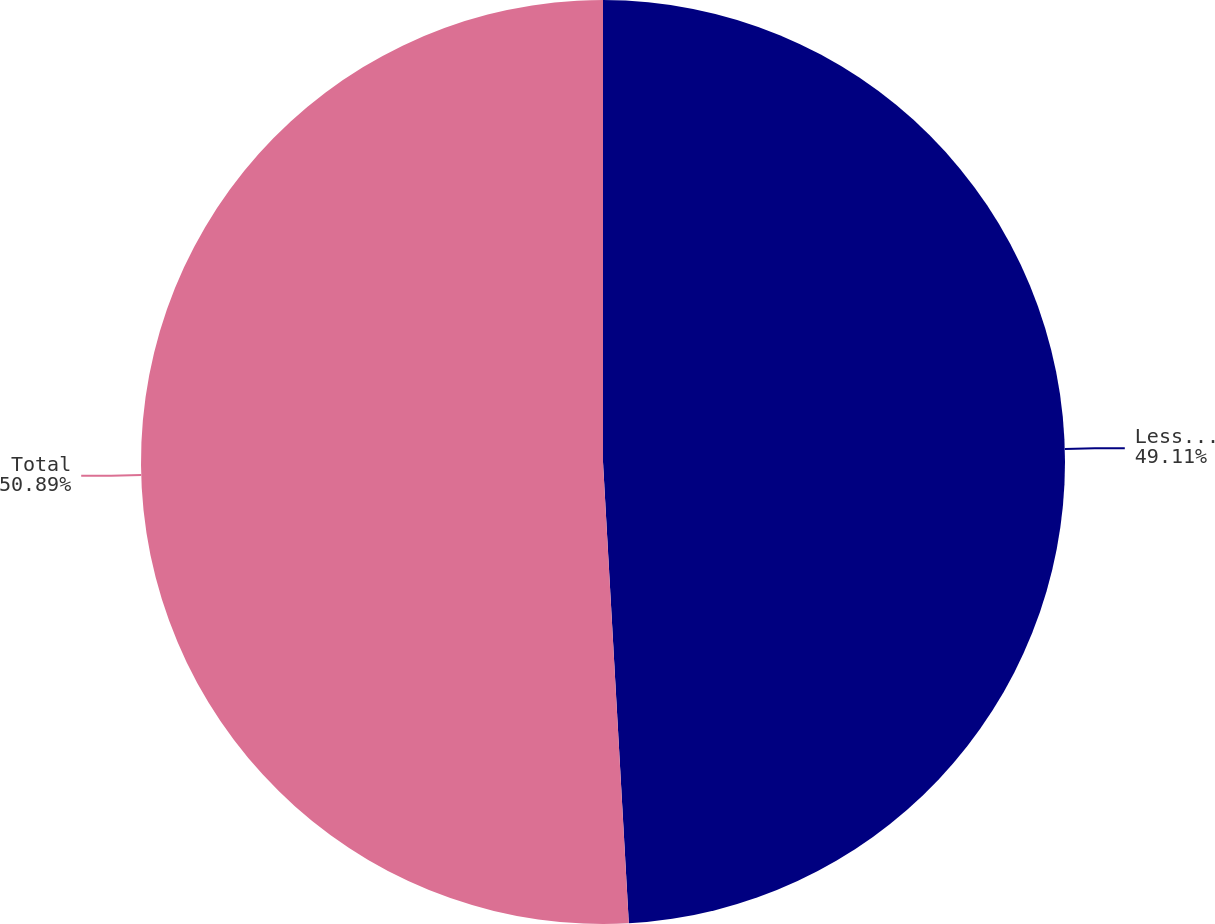Convert chart to OTSL. <chart><loc_0><loc_0><loc_500><loc_500><pie_chart><fcel>Less than 12 months<fcel>Total<nl><fcel>49.11%<fcel>50.89%<nl></chart> 